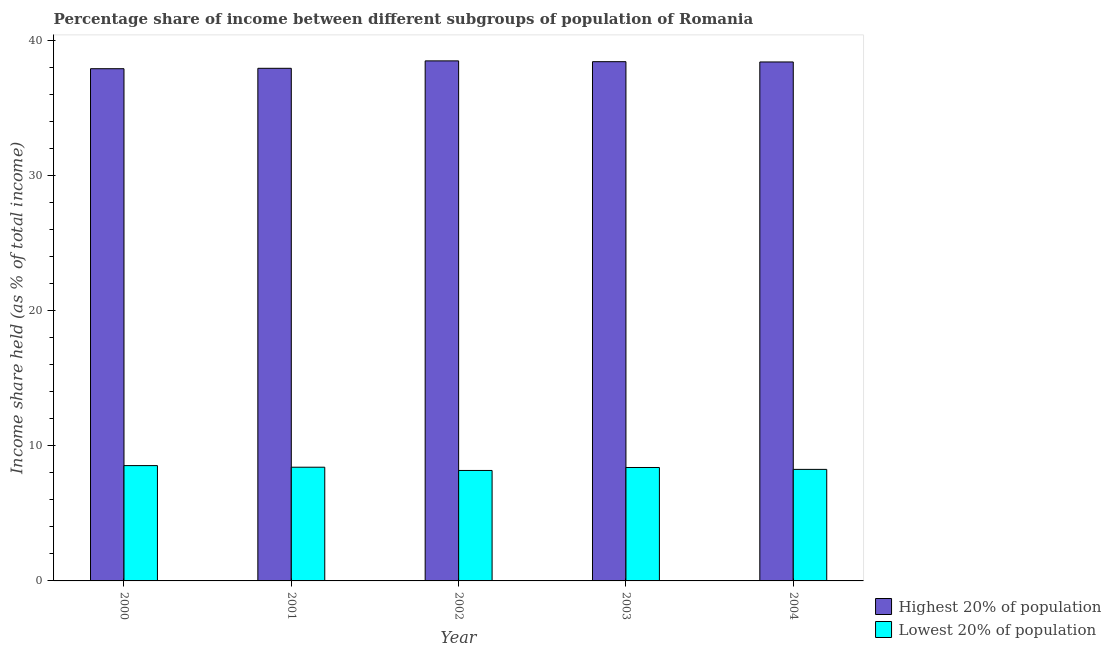How many different coloured bars are there?
Provide a succinct answer. 2. Are the number of bars per tick equal to the number of legend labels?
Provide a succinct answer. Yes. How many bars are there on the 1st tick from the left?
Offer a very short reply. 2. What is the label of the 4th group of bars from the left?
Provide a short and direct response. 2003. In how many cases, is the number of bars for a given year not equal to the number of legend labels?
Your response must be concise. 0. What is the income share held by lowest 20% of the population in 2004?
Provide a short and direct response. 8.26. Across all years, what is the maximum income share held by highest 20% of the population?
Make the answer very short. 38.51. Across all years, what is the minimum income share held by lowest 20% of the population?
Provide a short and direct response. 8.18. In which year was the income share held by highest 20% of the population minimum?
Offer a terse response. 2000. What is the total income share held by lowest 20% of the population in the graph?
Make the answer very short. 41.8. What is the difference between the income share held by lowest 20% of the population in 2001 and that in 2003?
Your answer should be very brief. 0.02. What is the difference between the income share held by highest 20% of the population in 2003 and the income share held by lowest 20% of the population in 2004?
Keep it short and to the point. 0.02. What is the average income share held by lowest 20% of the population per year?
Offer a terse response. 8.36. What is the ratio of the income share held by lowest 20% of the population in 2003 to that in 2004?
Your answer should be very brief. 1.02. Is the income share held by highest 20% of the population in 2001 less than that in 2003?
Give a very brief answer. Yes. What is the difference between the highest and the second highest income share held by lowest 20% of the population?
Make the answer very short. 0.12. What is the difference between the highest and the lowest income share held by highest 20% of the population?
Make the answer very short. 0.58. Is the sum of the income share held by highest 20% of the population in 2002 and 2004 greater than the maximum income share held by lowest 20% of the population across all years?
Give a very brief answer. Yes. What does the 1st bar from the left in 2002 represents?
Your answer should be compact. Highest 20% of population. What does the 2nd bar from the right in 2003 represents?
Your answer should be very brief. Highest 20% of population. How many bars are there?
Make the answer very short. 10. Are all the bars in the graph horizontal?
Give a very brief answer. No. How many years are there in the graph?
Your answer should be very brief. 5. Are the values on the major ticks of Y-axis written in scientific E-notation?
Offer a very short reply. No. Does the graph contain any zero values?
Offer a terse response. No. Does the graph contain grids?
Your answer should be compact. No. Where does the legend appear in the graph?
Provide a succinct answer. Bottom right. How are the legend labels stacked?
Offer a terse response. Vertical. What is the title of the graph?
Your response must be concise. Percentage share of income between different subgroups of population of Romania. Does "Private credit bureau" appear as one of the legend labels in the graph?
Make the answer very short. No. What is the label or title of the X-axis?
Provide a short and direct response. Year. What is the label or title of the Y-axis?
Offer a very short reply. Income share held (as % of total income). What is the Income share held (as % of total income) in Highest 20% of population in 2000?
Make the answer very short. 37.93. What is the Income share held (as % of total income) of Lowest 20% of population in 2000?
Make the answer very short. 8.54. What is the Income share held (as % of total income) of Highest 20% of population in 2001?
Offer a very short reply. 37.96. What is the Income share held (as % of total income) in Lowest 20% of population in 2001?
Ensure brevity in your answer.  8.42. What is the Income share held (as % of total income) of Highest 20% of population in 2002?
Your answer should be compact. 38.51. What is the Income share held (as % of total income) in Lowest 20% of population in 2002?
Your answer should be compact. 8.18. What is the Income share held (as % of total income) of Highest 20% of population in 2003?
Give a very brief answer. 38.45. What is the Income share held (as % of total income) of Lowest 20% of population in 2003?
Your answer should be compact. 8.4. What is the Income share held (as % of total income) of Highest 20% of population in 2004?
Your answer should be compact. 38.43. What is the Income share held (as % of total income) in Lowest 20% of population in 2004?
Offer a very short reply. 8.26. Across all years, what is the maximum Income share held (as % of total income) of Highest 20% of population?
Your answer should be compact. 38.51. Across all years, what is the maximum Income share held (as % of total income) of Lowest 20% of population?
Make the answer very short. 8.54. Across all years, what is the minimum Income share held (as % of total income) in Highest 20% of population?
Offer a very short reply. 37.93. Across all years, what is the minimum Income share held (as % of total income) in Lowest 20% of population?
Keep it short and to the point. 8.18. What is the total Income share held (as % of total income) of Highest 20% of population in the graph?
Your response must be concise. 191.28. What is the total Income share held (as % of total income) of Lowest 20% of population in the graph?
Your response must be concise. 41.8. What is the difference between the Income share held (as % of total income) of Highest 20% of population in 2000 and that in 2001?
Your response must be concise. -0.03. What is the difference between the Income share held (as % of total income) of Lowest 20% of population in 2000 and that in 2001?
Your answer should be compact. 0.12. What is the difference between the Income share held (as % of total income) of Highest 20% of population in 2000 and that in 2002?
Your response must be concise. -0.58. What is the difference between the Income share held (as % of total income) of Lowest 20% of population in 2000 and that in 2002?
Offer a terse response. 0.36. What is the difference between the Income share held (as % of total income) of Highest 20% of population in 2000 and that in 2003?
Your answer should be compact. -0.52. What is the difference between the Income share held (as % of total income) in Lowest 20% of population in 2000 and that in 2003?
Your response must be concise. 0.14. What is the difference between the Income share held (as % of total income) in Lowest 20% of population in 2000 and that in 2004?
Your response must be concise. 0.28. What is the difference between the Income share held (as % of total income) in Highest 20% of population in 2001 and that in 2002?
Provide a short and direct response. -0.55. What is the difference between the Income share held (as % of total income) in Lowest 20% of population in 2001 and that in 2002?
Provide a short and direct response. 0.24. What is the difference between the Income share held (as % of total income) in Highest 20% of population in 2001 and that in 2003?
Your response must be concise. -0.49. What is the difference between the Income share held (as % of total income) in Lowest 20% of population in 2001 and that in 2003?
Your answer should be very brief. 0.02. What is the difference between the Income share held (as % of total income) of Highest 20% of population in 2001 and that in 2004?
Make the answer very short. -0.47. What is the difference between the Income share held (as % of total income) in Lowest 20% of population in 2001 and that in 2004?
Provide a succinct answer. 0.16. What is the difference between the Income share held (as % of total income) of Highest 20% of population in 2002 and that in 2003?
Ensure brevity in your answer.  0.06. What is the difference between the Income share held (as % of total income) in Lowest 20% of population in 2002 and that in 2003?
Your response must be concise. -0.22. What is the difference between the Income share held (as % of total income) in Highest 20% of population in 2002 and that in 2004?
Ensure brevity in your answer.  0.08. What is the difference between the Income share held (as % of total income) in Lowest 20% of population in 2002 and that in 2004?
Ensure brevity in your answer.  -0.08. What is the difference between the Income share held (as % of total income) of Lowest 20% of population in 2003 and that in 2004?
Make the answer very short. 0.14. What is the difference between the Income share held (as % of total income) in Highest 20% of population in 2000 and the Income share held (as % of total income) in Lowest 20% of population in 2001?
Provide a short and direct response. 29.51. What is the difference between the Income share held (as % of total income) of Highest 20% of population in 2000 and the Income share held (as % of total income) of Lowest 20% of population in 2002?
Provide a succinct answer. 29.75. What is the difference between the Income share held (as % of total income) of Highest 20% of population in 2000 and the Income share held (as % of total income) of Lowest 20% of population in 2003?
Your answer should be compact. 29.53. What is the difference between the Income share held (as % of total income) in Highest 20% of population in 2000 and the Income share held (as % of total income) in Lowest 20% of population in 2004?
Your answer should be very brief. 29.67. What is the difference between the Income share held (as % of total income) of Highest 20% of population in 2001 and the Income share held (as % of total income) of Lowest 20% of population in 2002?
Give a very brief answer. 29.78. What is the difference between the Income share held (as % of total income) of Highest 20% of population in 2001 and the Income share held (as % of total income) of Lowest 20% of population in 2003?
Provide a short and direct response. 29.56. What is the difference between the Income share held (as % of total income) in Highest 20% of population in 2001 and the Income share held (as % of total income) in Lowest 20% of population in 2004?
Keep it short and to the point. 29.7. What is the difference between the Income share held (as % of total income) in Highest 20% of population in 2002 and the Income share held (as % of total income) in Lowest 20% of population in 2003?
Provide a short and direct response. 30.11. What is the difference between the Income share held (as % of total income) in Highest 20% of population in 2002 and the Income share held (as % of total income) in Lowest 20% of population in 2004?
Keep it short and to the point. 30.25. What is the difference between the Income share held (as % of total income) of Highest 20% of population in 2003 and the Income share held (as % of total income) of Lowest 20% of population in 2004?
Keep it short and to the point. 30.19. What is the average Income share held (as % of total income) in Highest 20% of population per year?
Your answer should be very brief. 38.26. What is the average Income share held (as % of total income) in Lowest 20% of population per year?
Your answer should be compact. 8.36. In the year 2000, what is the difference between the Income share held (as % of total income) of Highest 20% of population and Income share held (as % of total income) of Lowest 20% of population?
Your answer should be compact. 29.39. In the year 2001, what is the difference between the Income share held (as % of total income) of Highest 20% of population and Income share held (as % of total income) of Lowest 20% of population?
Keep it short and to the point. 29.54. In the year 2002, what is the difference between the Income share held (as % of total income) of Highest 20% of population and Income share held (as % of total income) of Lowest 20% of population?
Offer a terse response. 30.33. In the year 2003, what is the difference between the Income share held (as % of total income) in Highest 20% of population and Income share held (as % of total income) in Lowest 20% of population?
Make the answer very short. 30.05. In the year 2004, what is the difference between the Income share held (as % of total income) in Highest 20% of population and Income share held (as % of total income) in Lowest 20% of population?
Your answer should be very brief. 30.17. What is the ratio of the Income share held (as % of total income) of Lowest 20% of population in 2000 to that in 2001?
Offer a very short reply. 1.01. What is the ratio of the Income share held (as % of total income) in Highest 20% of population in 2000 to that in 2002?
Offer a terse response. 0.98. What is the ratio of the Income share held (as % of total income) in Lowest 20% of population in 2000 to that in 2002?
Provide a succinct answer. 1.04. What is the ratio of the Income share held (as % of total income) of Highest 20% of population in 2000 to that in 2003?
Provide a succinct answer. 0.99. What is the ratio of the Income share held (as % of total income) in Lowest 20% of population in 2000 to that in 2003?
Your response must be concise. 1.02. What is the ratio of the Income share held (as % of total income) of Highest 20% of population in 2000 to that in 2004?
Your response must be concise. 0.99. What is the ratio of the Income share held (as % of total income) in Lowest 20% of population in 2000 to that in 2004?
Offer a terse response. 1.03. What is the ratio of the Income share held (as % of total income) of Highest 20% of population in 2001 to that in 2002?
Ensure brevity in your answer.  0.99. What is the ratio of the Income share held (as % of total income) in Lowest 20% of population in 2001 to that in 2002?
Your answer should be compact. 1.03. What is the ratio of the Income share held (as % of total income) in Highest 20% of population in 2001 to that in 2003?
Keep it short and to the point. 0.99. What is the ratio of the Income share held (as % of total income) in Lowest 20% of population in 2001 to that in 2003?
Keep it short and to the point. 1. What is the ratio of the Income share held (as % of total income) of Lowest 20% of population in 2001 to that in 2004?
Give a very brief answer. 1.02. What is the ratio of the Income share held (as % of total income) of Lowest 20% of population in 2002 to that in 2003?
Provide a short and direct response. 0.97. What is the ratio of the Income share held (as % of total income) of Lowest 20% of population in 2002 to that in 2004?
Make the answer very short. 0.99. What is the ratio of the Income share held (as % of total income) in Lowest 20% of population in 2003 to that in 2004?
Provide a succinct answer. 1.02. What is the difference between the highest and the second highest Income share held (as % of total income) in Highest 20% of population?
Offer a very short reply. 0.06. What is the difference between the highest and the second highest Income share held (as % of total income) in Lowest 20% of population?
Your response must be concise. 0.12. What is the difference between the highest and the lowest Income share held (as % of total income) in Highest 20% of population?
Offer a very short reply. 0.58. What is the difference between the highest and the lowest Income share held (as % of total income) of Lowest 20% of population?
Provide a succinct answer. 0.36. 